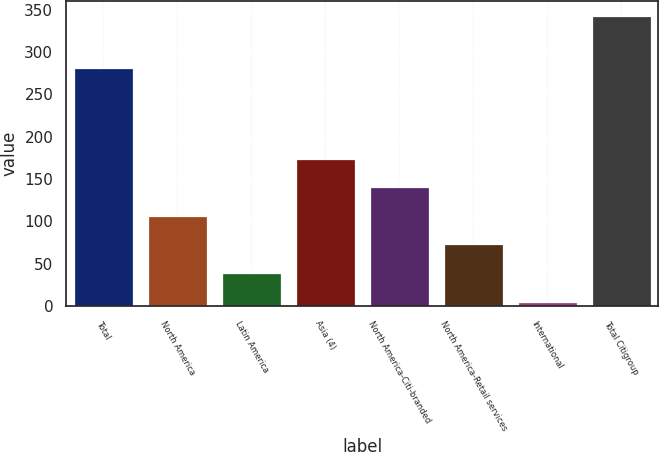Convert chart. <chart><loc_0><loc_0><loc_500><loc_500><bar_chart><fcel>Total<fcel>North America<fcel>Latin America<fcel>Asia (4)<fcel>North America-Citi-branded<fcel>North America-Retail services<fcel>International<fcel>Total Citigroup<nl><fcel>281.3<fcel>106.37<fcel>38.79<fcel>173.95<fcel>140.16<fcel>72.58<fcel>5<fcel>342.9<nl></chart> 